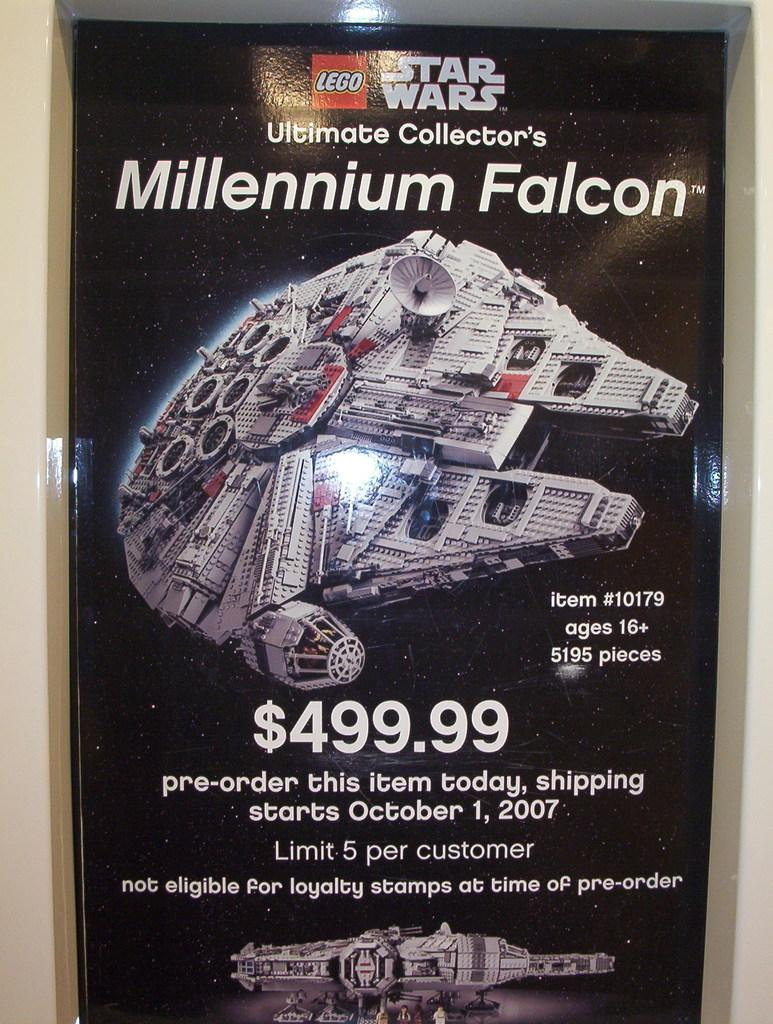Provide a one-sentence caption for the provided image. A flyer for Lego Star Wars Millennium Falcon that is on sale for $499.99, which releases on October 1, 2007. 